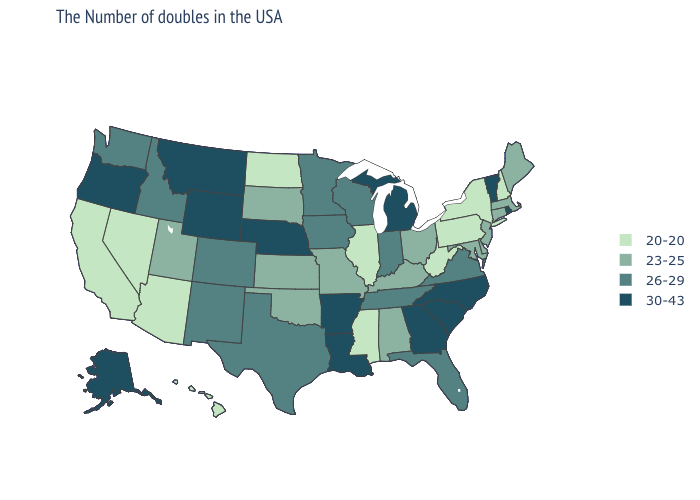Which states have the lowest value in the South?
Give a very brief answer. West Virginia, Mississippi. What is the value of Wyoming?
Write a very short answer. 30-43. Which states have the lowest value in the Northeast?
Be succinct. New Hampshire, New York, Pennsylvania. Does Michigan have the highest value in the MidWest?
Short answer required. Yes. Does the first symbol in the legend represent the smallest category?
Concise answer only. Yes. Among the states that border Oklahoma , which have the highest value?
Quick response, please. Arkansas. Which states have the lowest value in the MidWest?
Short answer required. Illinois, North Dakota. Name the states that have a value in the range 20-20?
Write a very short answer. New Hampshire, New York, Pennsylvania, West Virginia, Illinois, Mississippi, North Dakota, Arizona, Nevada, California, Hawaii. Does Michigan have the highest value in the USA?
Answer briefly. Yes. What is the lowest value in the Northeast?
Be succinct. 20-20. How many symbols are there in the legend?
Give a very brief answer. 4. Does New Mexico have the lowest value in the USA?
Keep it brief. No. What is the value of Delaware?
Keep it brief. 23-25. What is the value of West Virginia?
Short answer required. 20-20. 